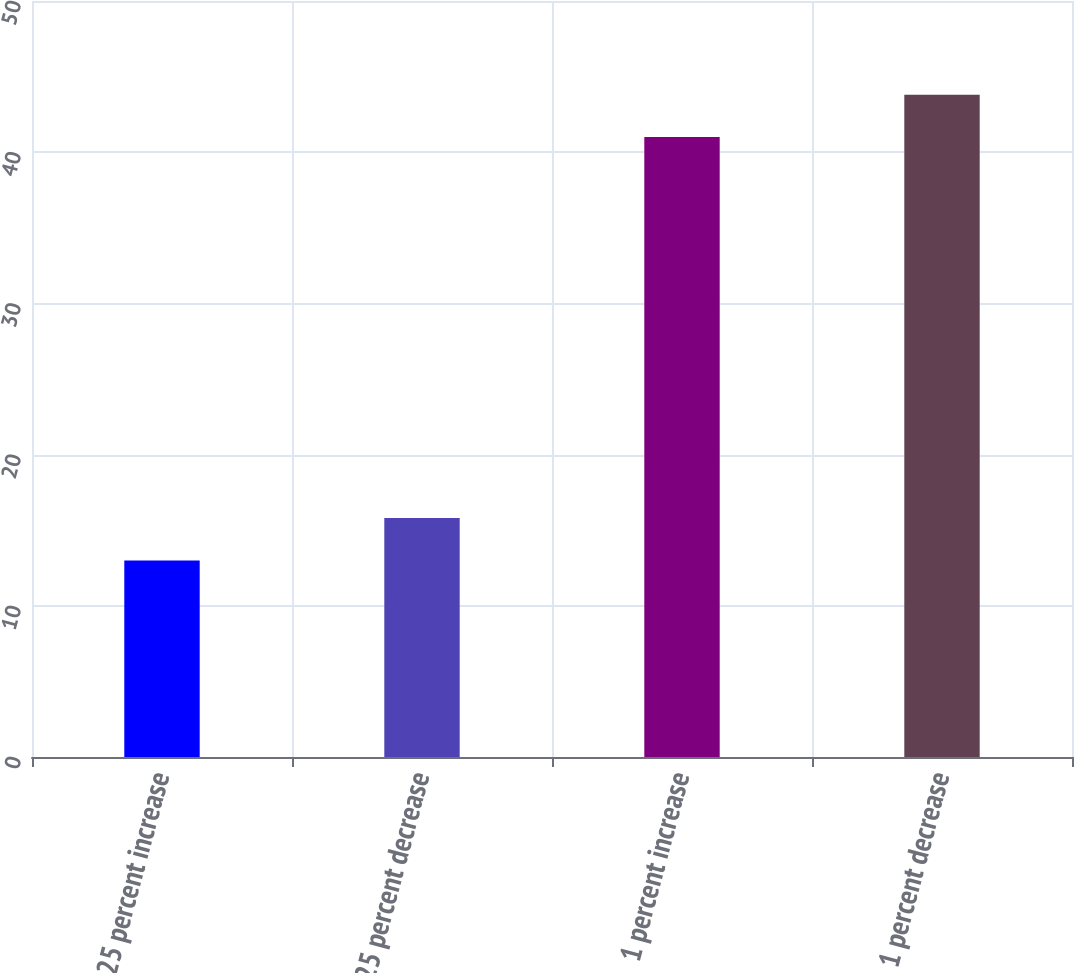Convert chart to OTSL. <chart><loc_0><loc_0><loc_500><loc_500><bar_chart><fcel>025 percent increase<fcel>025 percent decrease<fcel>1 percent increase<fcel>1 percent decrease<nl><fcel>13<fcel>15.8<fcel>41<fcel>43.8<nl></chart> 